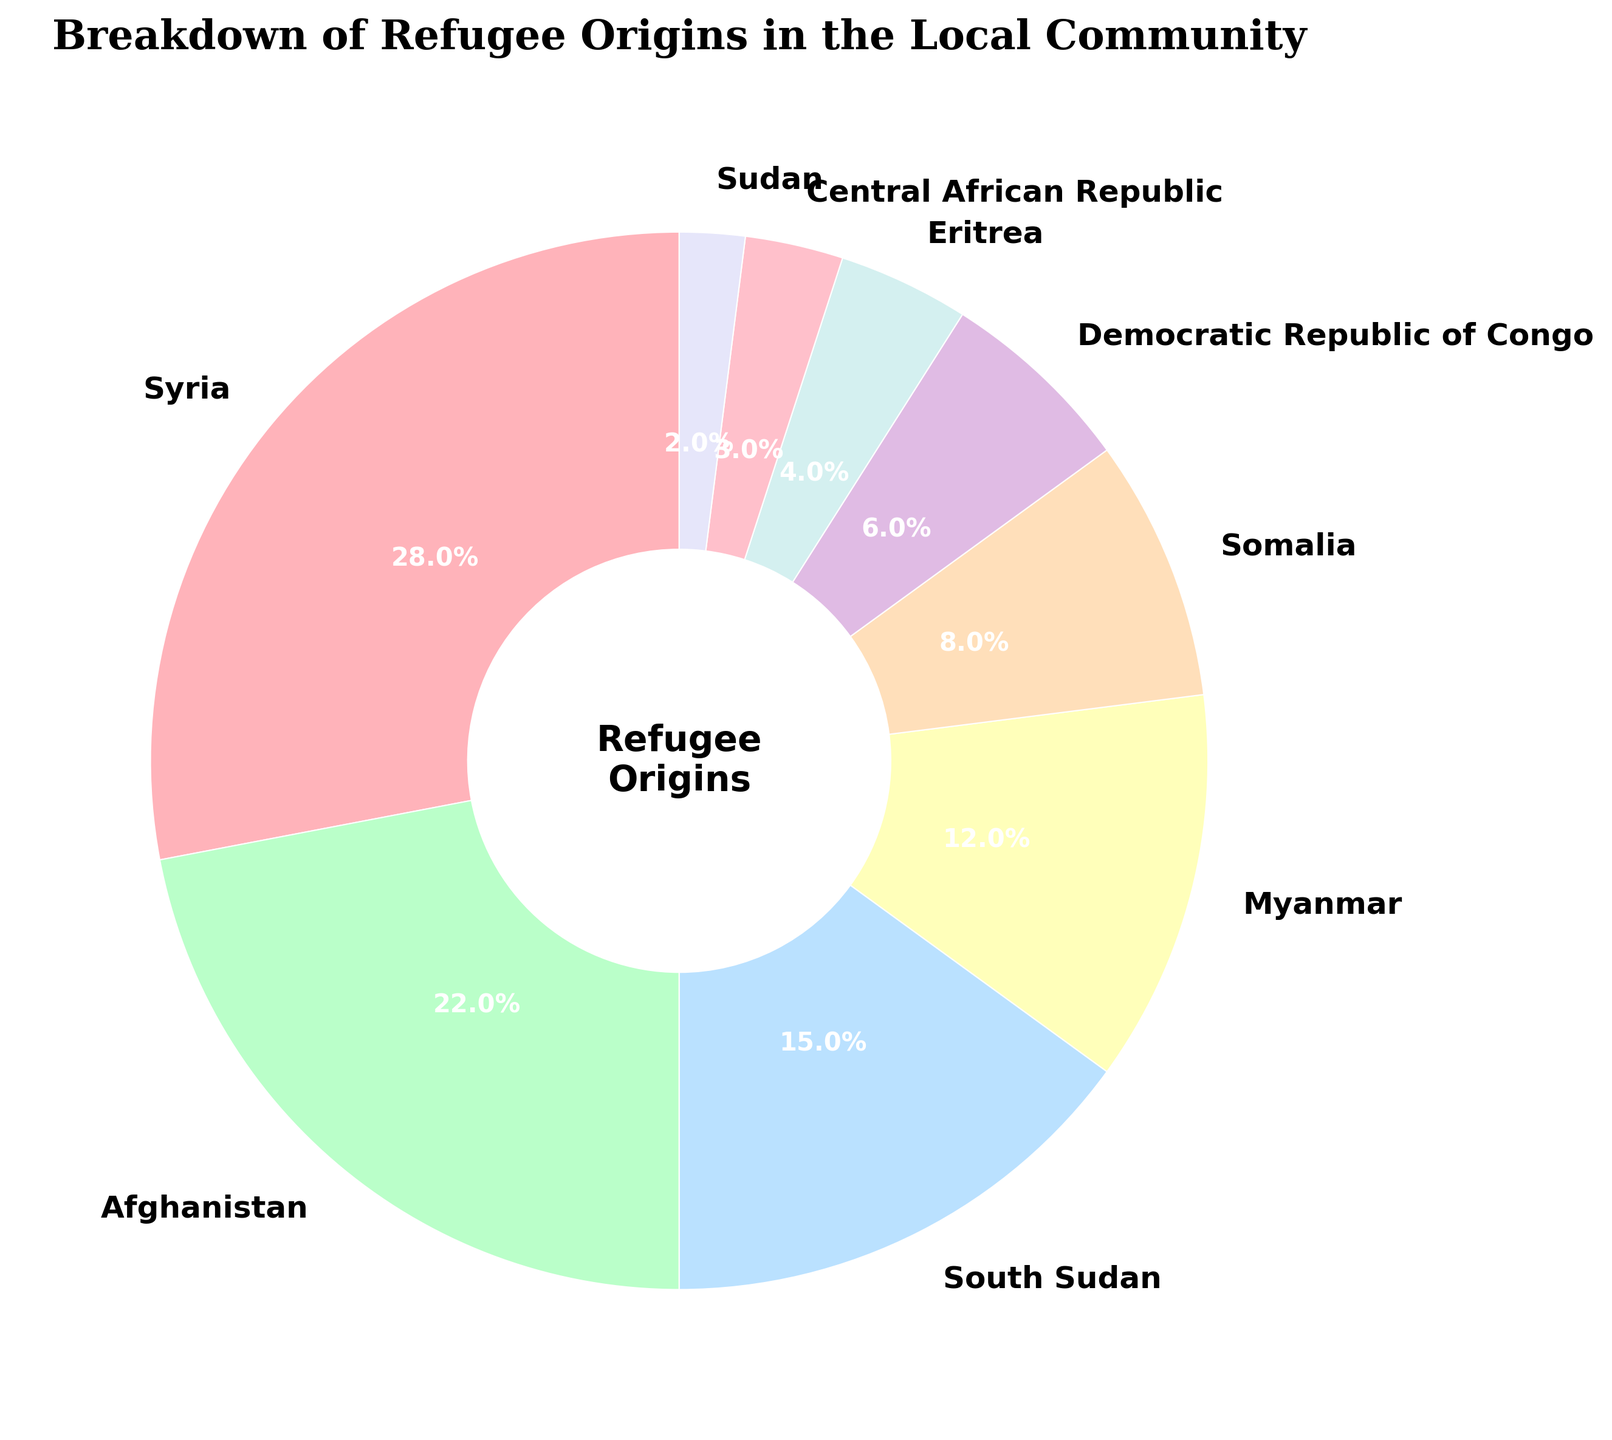What percentage of refugees in the local community are from Syria? From the chart, identify the segment labeled "Syria" and note its percentage.
Answer: 28% Which country has the second highest percentage of refugees in the local community? Compare the percentages of all the countries and identify the one with the second highest percentage after Syria.
Answer: Afghanistan How much larger is the Syrian refugee population compared to the Somalian refugee population? Find the percentage of Syrian refugees (28%) and Somalian refugees (8%), then subtract the smaller percentage from the larger percentage: 28% - 8% = 20%.
Answer: 20% What is the combined percentage of refugees from Myanmar, Central African Republic, and Sudan? Add the percentages for Myanmar (12%), Central African Republic (3%), and Sudan (2%): 12% + 3% + 2% = 17%.
Answer: 17% Which countries have refugee populations that collectively exceed half of the local community's total refugee population? Sum the percentages of the countries in descending order until the total exceeds 50%: Syria (28%) + Afghanistan (22%) = 50%, adding any more countries will exceed half.
Answer: Syria, Afghanistan What is the smallest refugee population percentage shown on the chart, and which country does it correspond to? Identify the smallest percentage value on the chart and note the associated country: Sudan with 2%.
Answer: Sudan, 2% How much greater is the combined refugee population from Syria and Afghanistan compared to the combined population from South Sudan and Myanmar? First, find the combined percentages: Syria and Afghanistan (28% + 22% = 50%), South Sudan and Myanmar (15% + 12% = 27%). Then subtract the smaller sum from the larger sum: 50% - 27% = 23%.
Answer: 23% What are the colors used for the segments representing Eritrea and Democratic Republic of Congo? Note the color of the segment labeled "Eritrea" and the one labeled "Democratic Republic of Congo". Eritrea is in pink, Democratic Republic of Congo is in light purple.
Answer: Eritrea is pink, Democratic Republic of Congo is light purple 